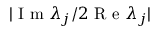<formula> <loc_0><loc_0><loc_500><loc_500>| I m \lambda _ { j } / 2 R e \lambda _ { j } |</formula> 